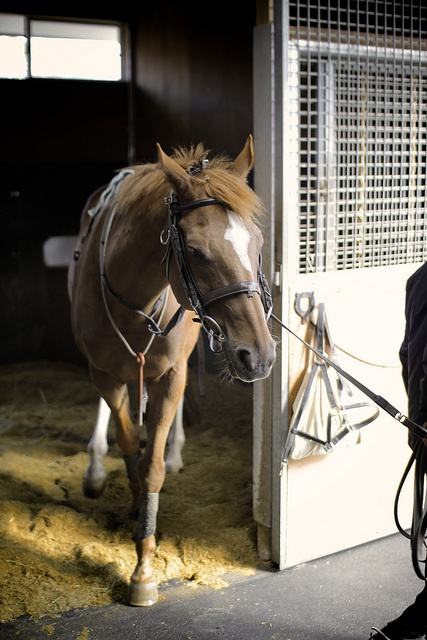Describe the objects in this image and their specific colors. I can see horse in black, gray, and tan tones and people in black, gray, and olive tones in this image. 